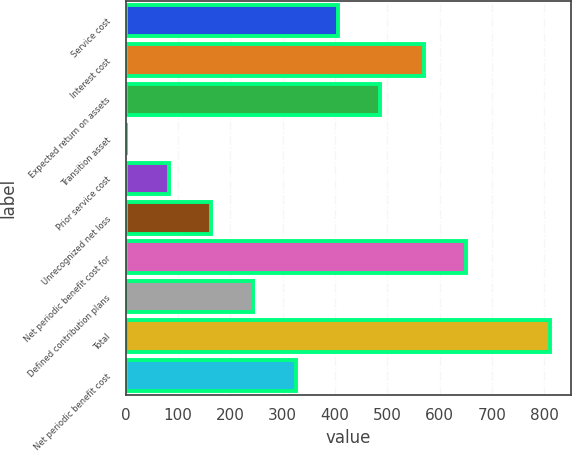Convert chart to OTSL. <chart><loc_0><loc_0><loc_500><loc_500><bar_chart><fcel>Service cost<fcel>Interest cost<fcel>Expected return on assets<fcel>Transition asset<fcel>Prior service cost<fcel>Unrecognized net loss<fcel>Net periodic benefit cost for<fcel>Defined contribution plans<fcel>Total<fcel>Net periodic benefit cost<nl><fcel>405.5<fcel>569<fcel>486.4<fcel>1<fcel>81.9<fcel>162.8<fcel>649.9<fcel>243.7<fcel>810<fcel>324.6<nl></chart> 